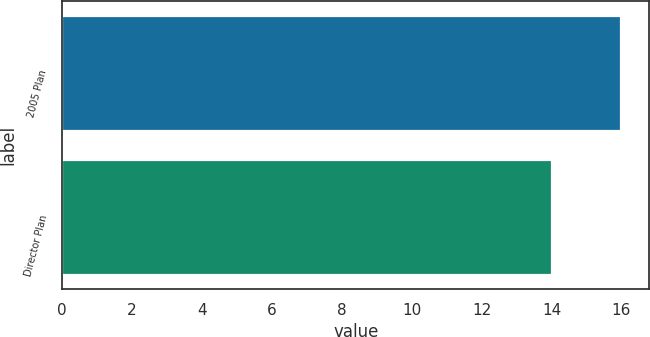Convert chart. <chart><loc_0><loc_0><loc_500><loc_500><bar_chart><fcel>2005 Plan<fcel>Director Plan<nl><fcel>16<fcel>14<nl></chart> 